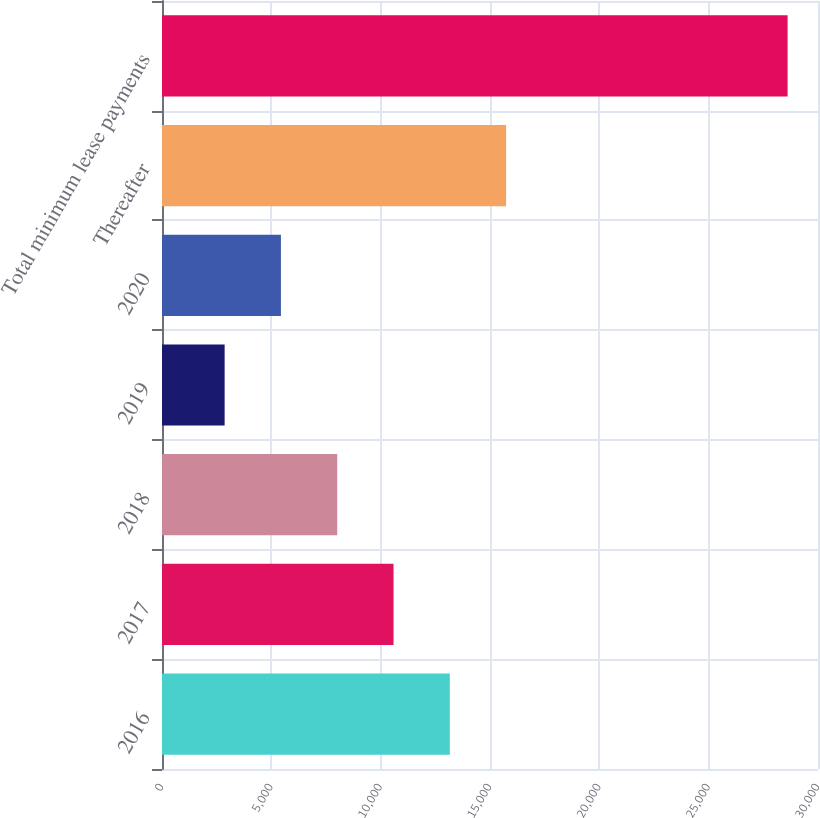<chart> <loc_0><loc_0><loc_500><loc_500><bar_chart><fcel>2016<fcel>2017<fcel>2018<fcel>2019<fcel>2020<fcel>Thereafter<fcel>Total minimum lease payments<nl><fcel>13162.4<fcel>10587.8<fcel>8013.2<fcel>2864<fcel>5438.6<fcel>15737<fcel>28610<nl></chart> 